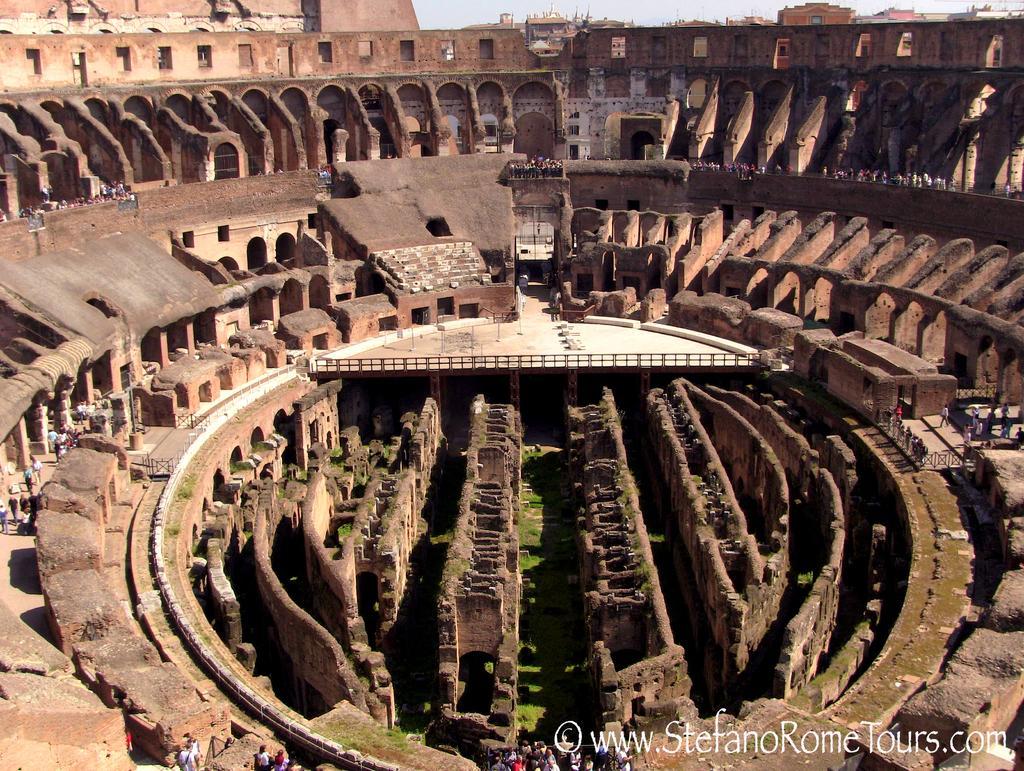Describe this image in one or two sentences. In this picture we can see a Colosseum. Some grass is visible on the ground. There are a few people visible from left to right. We can see a text in the bottom right. 